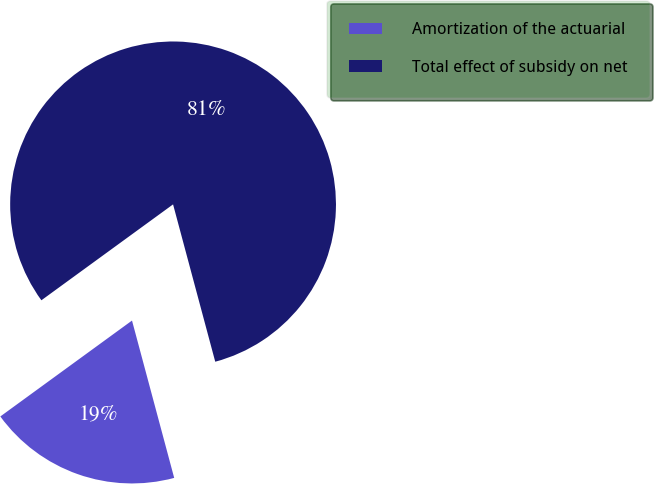Convert chart to OTSL. <chart><loc_0><loc_0><loc_500><loc_500><pie_chart><fcel>Amortization of the actuarial<fcel>Total effect of subsidy on net<nl><fcel>19.15%<fcel>80.85%<nl></chart> 